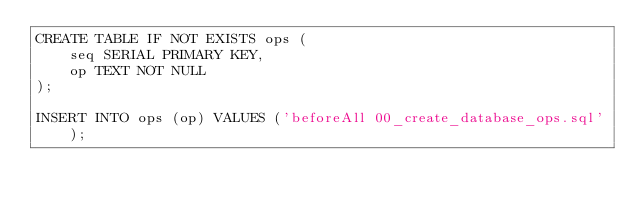Convert code to text. <code><loc_0><loc_0><loc_500><loc_500><_SQL_>CREATE TABLE IF NOT EXISTS ops (
    seq SERIAL PRIMARY KEY,
    op TEXT NOT NULL
);

INSERT INTO ops (op) VALUES ('beforeAll 00_create_database_ops.sql');
</code> 